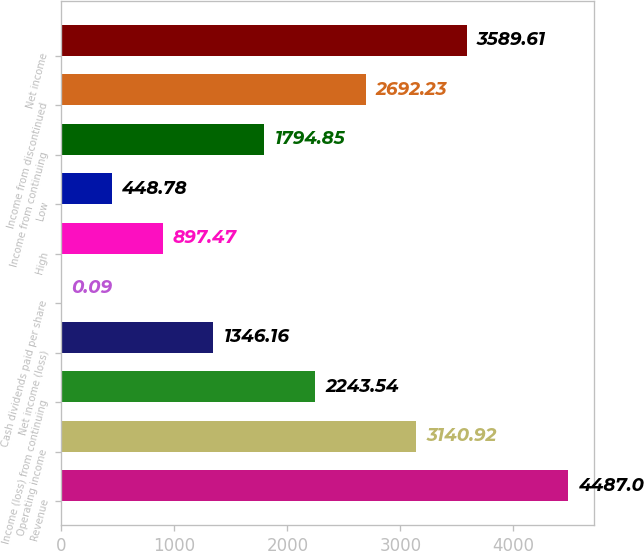Convert chart to OTSL. <chart><loc_0><loc_0><loc_500><loc_500><bar_chart><fcel>Revenue<fcel>Operating income<fcel>Income (loss) from continuing<fcel>Net income (loss)<fcel>Cash dividends paid per share<fcel>High<fcel>Low<fcel>Income from continuing<fcel>Income from discontinued<fcel>Net income<nl><fcel>4487<fcel>3140.92<fcel>2243.54<fcel>1346.16<fcel>0.09<fcel>897.47<fcel>448.78<fcel>1794.85<fcel>2692.23<fcel>3589.61<nl></chart> 